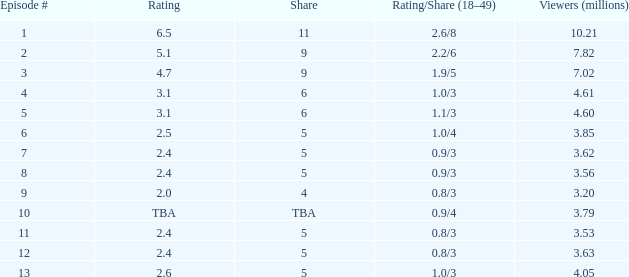What is the first episode that received a 0.9/4 rating/share and attracted at least 3.79 million viewers? None. 